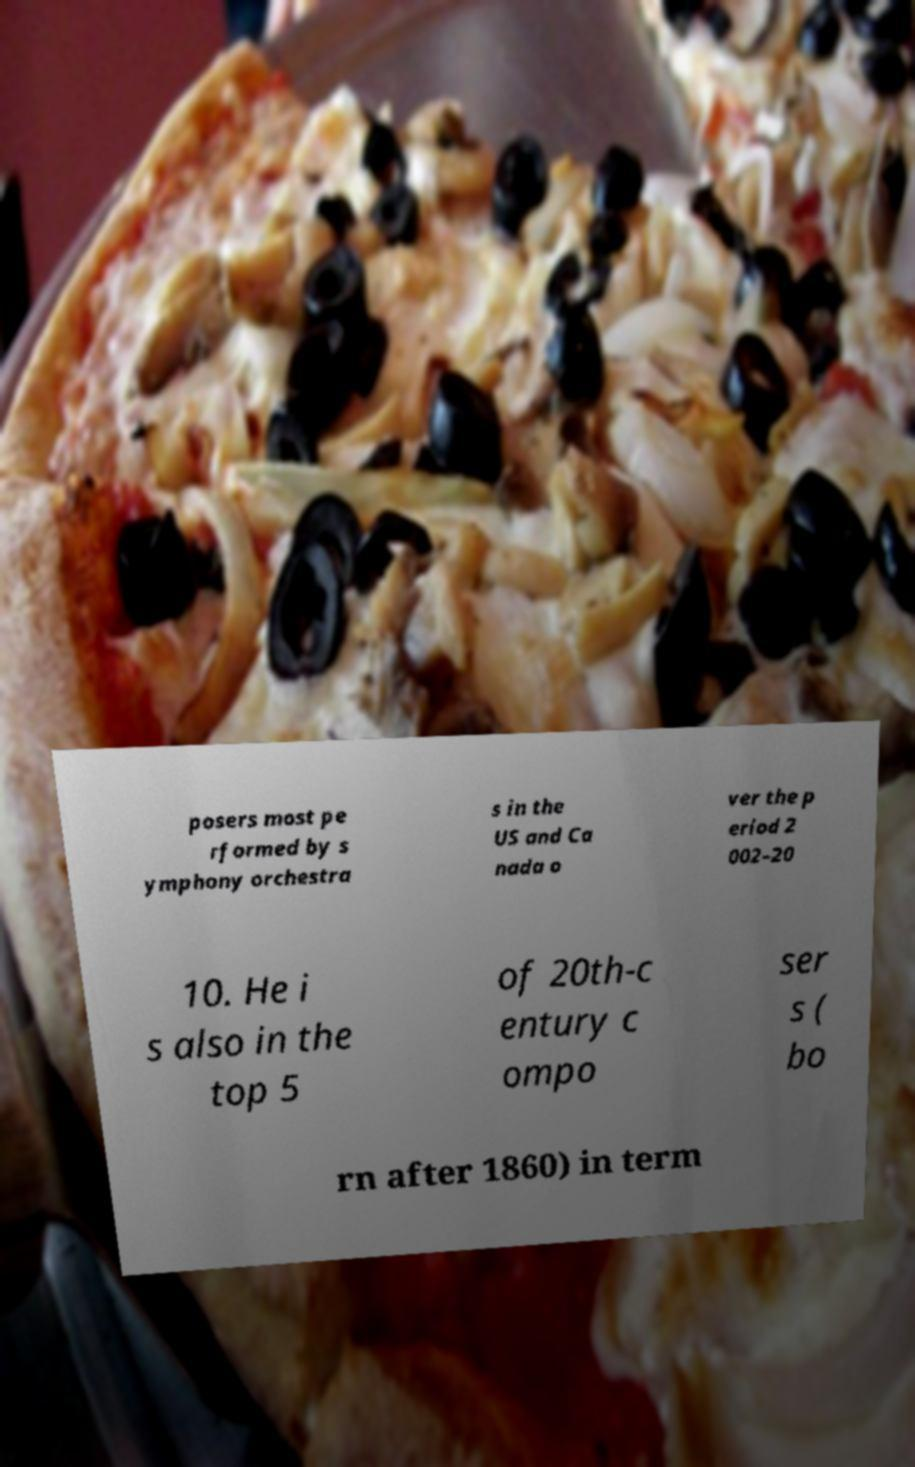Can you accurately transcribe the text from the provided image for me? posers most pe rformed by s ymphony orchestra s in the US and Ca nada o ver the p eriod 2 002–20 10. He i s also in the top 5 of 20th-c entury c ompo ser s ( bo rn after 1860) in term 